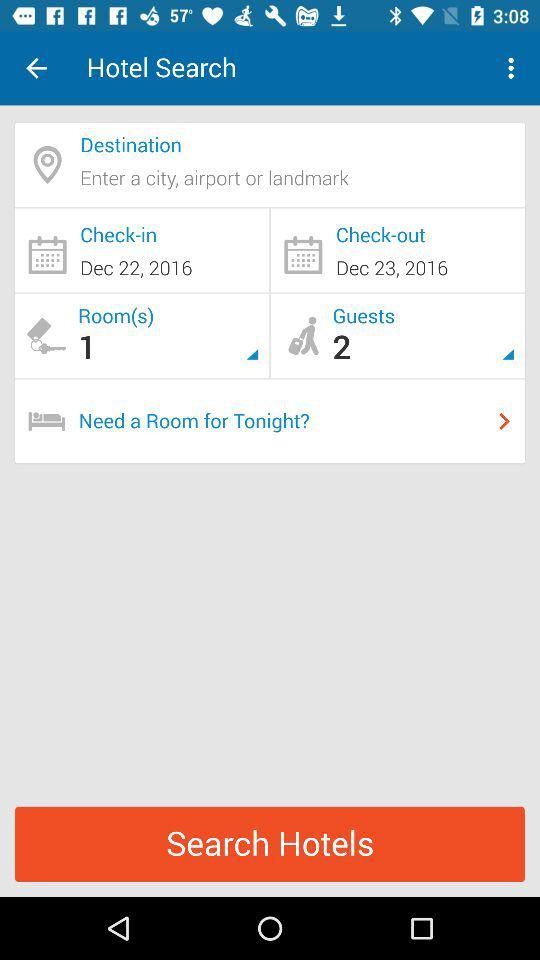What is the hotel check-in date? The hotel check-in date is December 22, 2016. 